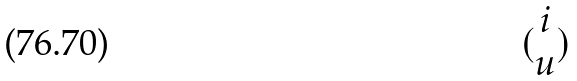<formula> <loc_0><loc_0><loc_500><loc_500>( \begin{matrix} i \\ u \end{matrix} )</formula> 